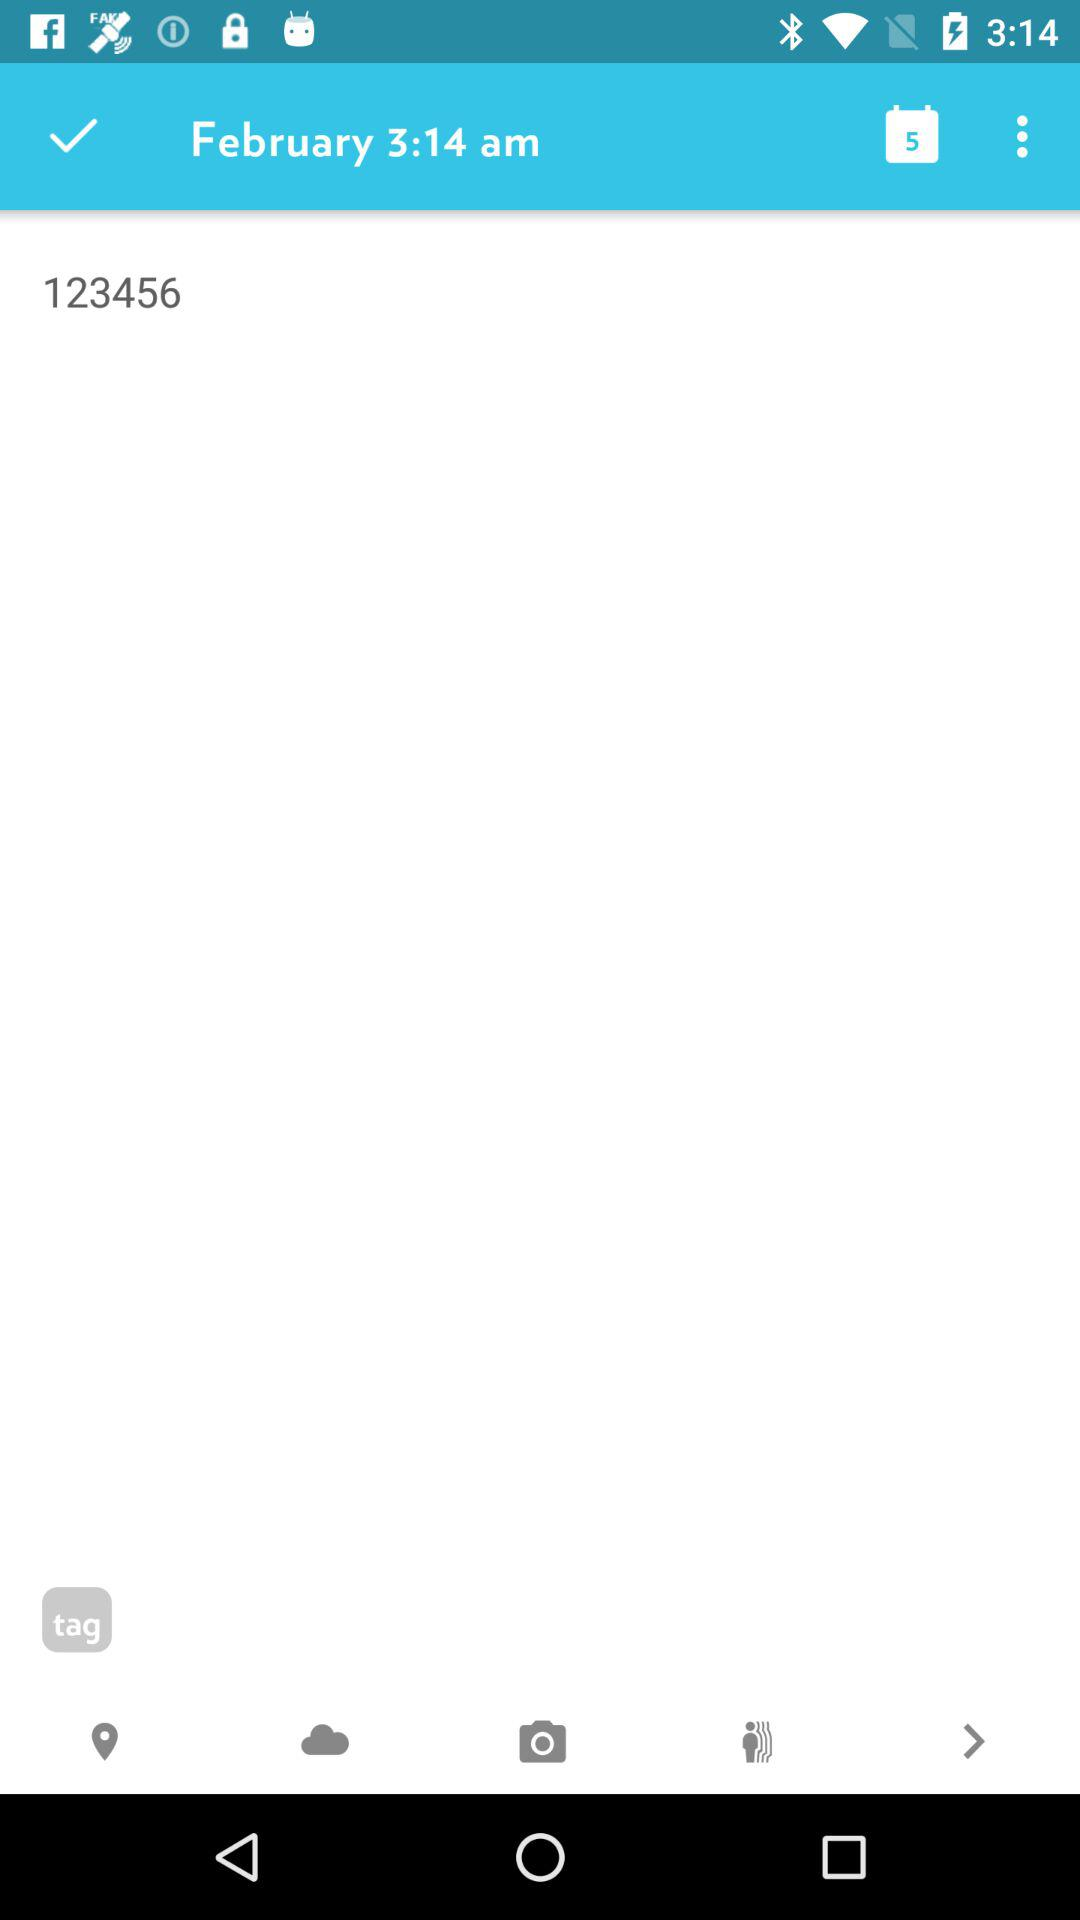What is the time? The time is 3:14 am. 